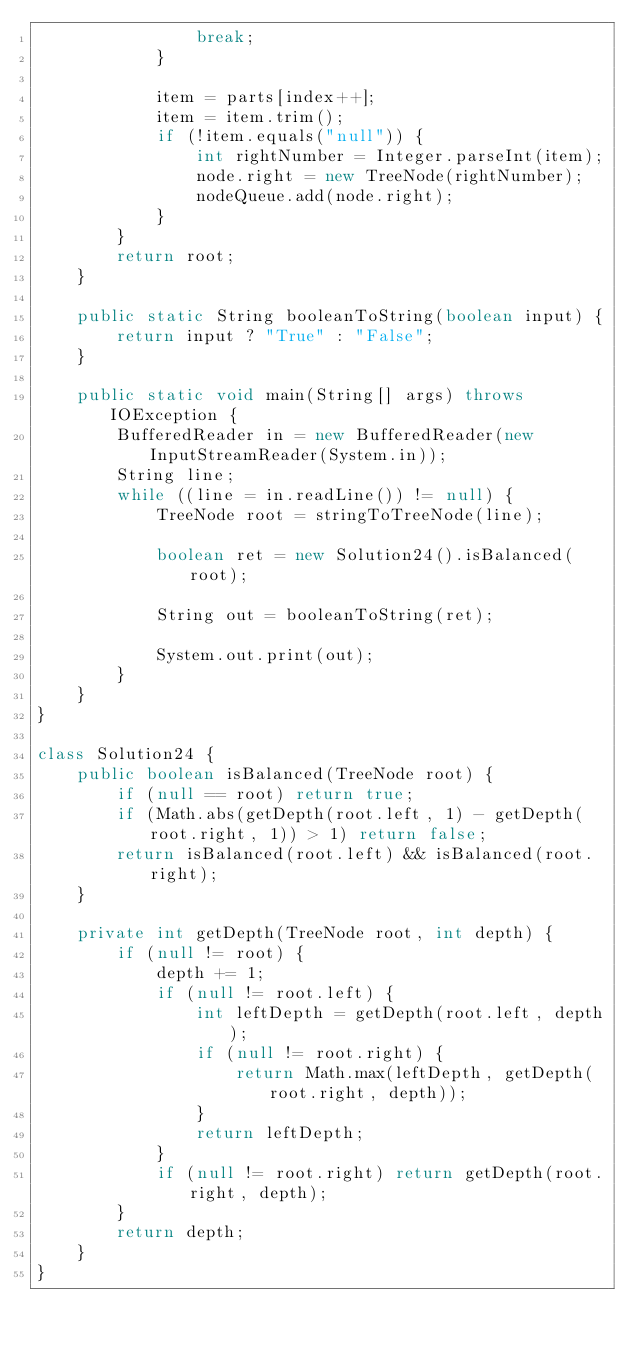Convert code to text. <code><loc_0><loc_0><loc_500><loc_500><_Java_>                break;
            }

            item = parts[index++];
            item = item.trim();
            if (!item.equals("null")) {
                int rightNumber = Integer.parseInt(item);
                node.right = new TreeNode(rightNumber);
                nodeQueue.add(node.right);
            }
        }
        return root;
    }

    public static String booleanToString(boolean input) {
        return input ? "True" : "False";
    }

    public static void main(String[] args) throws IOException {
        BufferedReader in = new BufferedReader(new InputStreamReader(System.in));
        String line;
        while ((line = in.readLine()) != null) {
            TreeNode root = stringToTreeNode(line);

            boolean ret = new Solution24().isBalanced(root);

            String out = booleanToString(ret);

            System.out.print(out);
        }
    }
}

class Solution24 {
    public boolean isBalanced(TreeNode root) {
        if (null == root) return true;
        if (Math.abs(getDepth(root.left, 1) - getDepth(root.right, 1)) > 1) return false;
        return isBalanced(root.left) && isBalanced(root.right);
    }

    private int getDepth(TreeNode root, int depth) {
        if (null != root) {
            depth += 1;
            if (null != root.left) {
                int leftDepth = getDepth(root.left, depth);
                if (null != root.right) {
                    return Math.max(leftDepth, getDepth(root.right, depth));
                }
                return leftDepth;
            }
            if (null != root.right) return getDepth(root.right, depth);
        }
        return depth;
    }
}</code> 